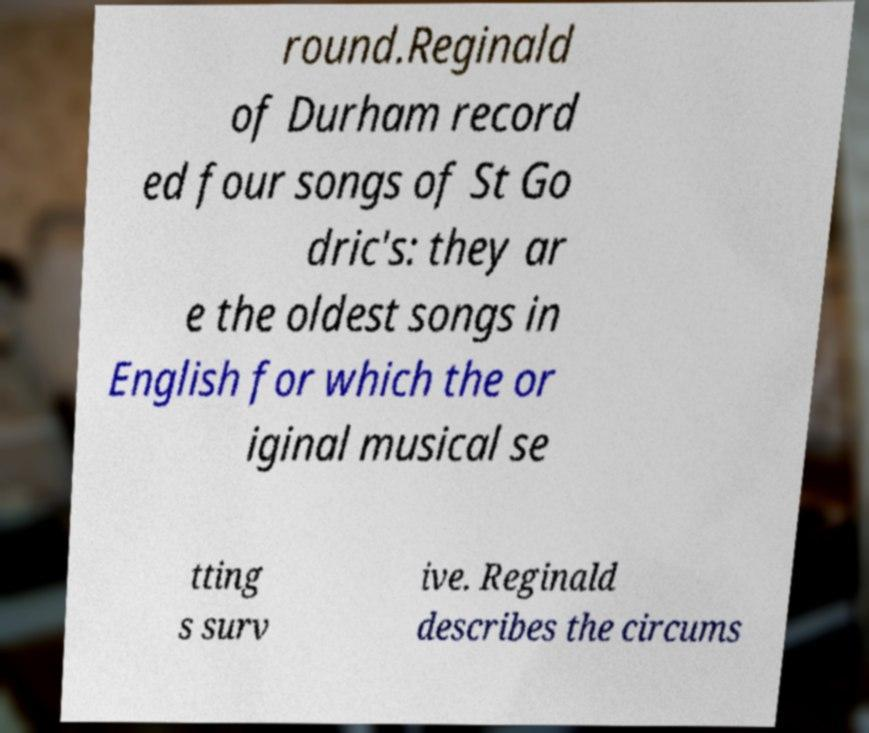Can you accurately transcribe the text from the provided image for me? round.Reginald of Durham record ed four songs of St Go dric's: they ar e the oldest songs in English for which the or iginal musical se tting s surv ive. Reginald describes the circums 